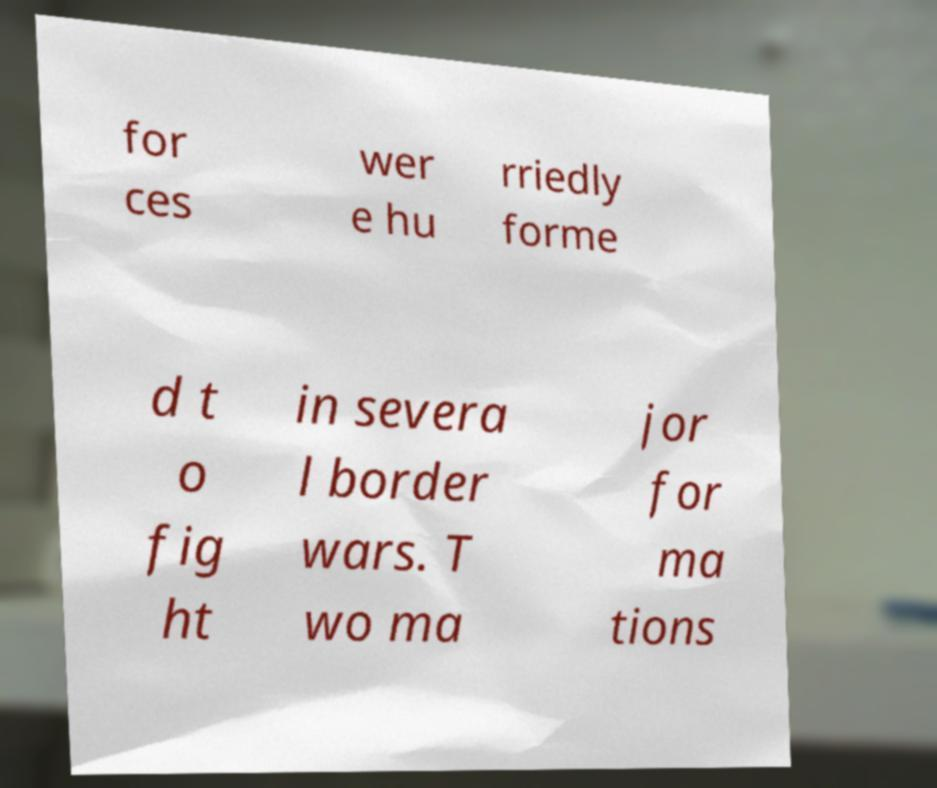There's text embedded in this image that I need extracted. Can you transcribe it verbatim? for ces wer e hu rriedly forme d t o fig ht in severa l border wars. T wo ma jor for ma tions 